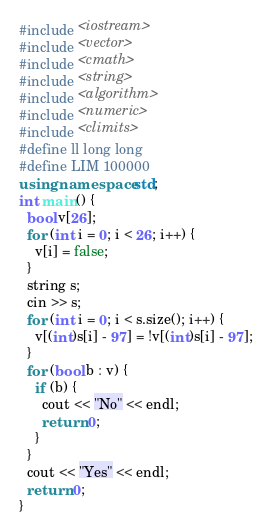<code> <loc_0><loc_0><loc_500><loc_500><_C++_>#include <iostream>
#include <vector>
#include <cmath>
#include <string>
#include <algorithm>
#include <numeric>
#include <climits>
#define ll long long
#define LIM 100000
using namespace std;
int main() {
  bool v[26];
  for (int i = 0; i < 26; i++) {
    v[i] = false;
  }
  string s;
  cin >> s;
  for (int i = 0; i < s.size(); i++) {
    v[(int)s[i] - 97] = !v[(int)s[i] - 97];
  }
  for (bool b : v) {
    if (b) {
      cout << "No" << endl;
      return 0;
    }
  }
  cout << "Yes" << endl;
  return 0;
}
</code> 